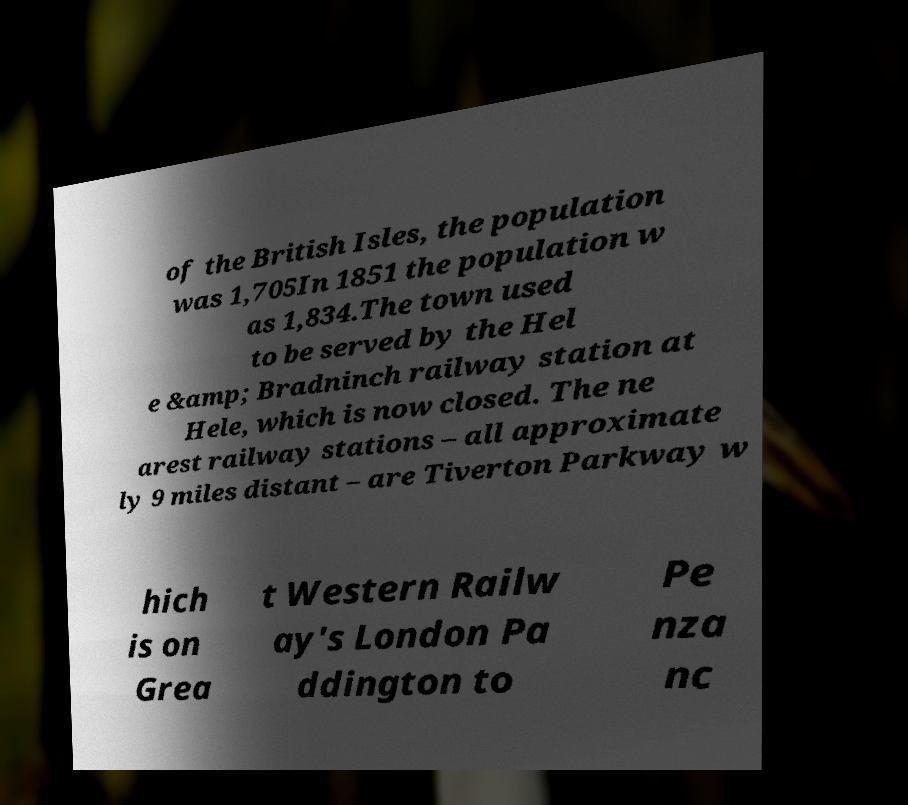I need the written content from this picture converted into text. Can you do that? of the British Isles, the population was 1,705In 1851 the population w as 1,834.The town used to be served by the Hel e &amp; Bradninch railway station at Hele, which is now closed. The ne arest railway stations – all approximate ly 9 miles distant – are Tiverton Parkway w hich is on Grea t Western Railw ay's London Pa ddington to Pe nza nc 